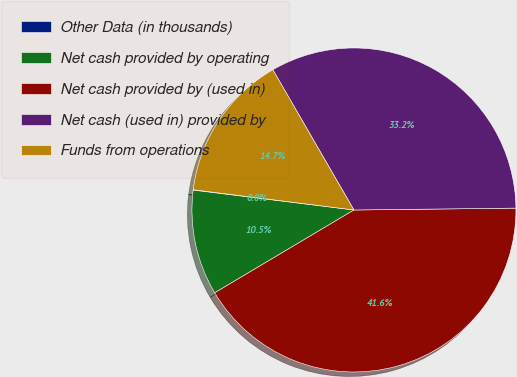<chart> <loc_0><loc_0><loc_500><loc_500><pie_chart><fcel>Other Data (in thousands)<fcel>Net cash provided by operating<fcel>Net cash provided by (used in)<fcel>Net cash (used in) provided by<fcel>Funds from operations<nl><fcel>0.04%<fcel>10.5%<fcel>41.64%<fcel>33.16%<fcel>14.66%<nl></chart> 